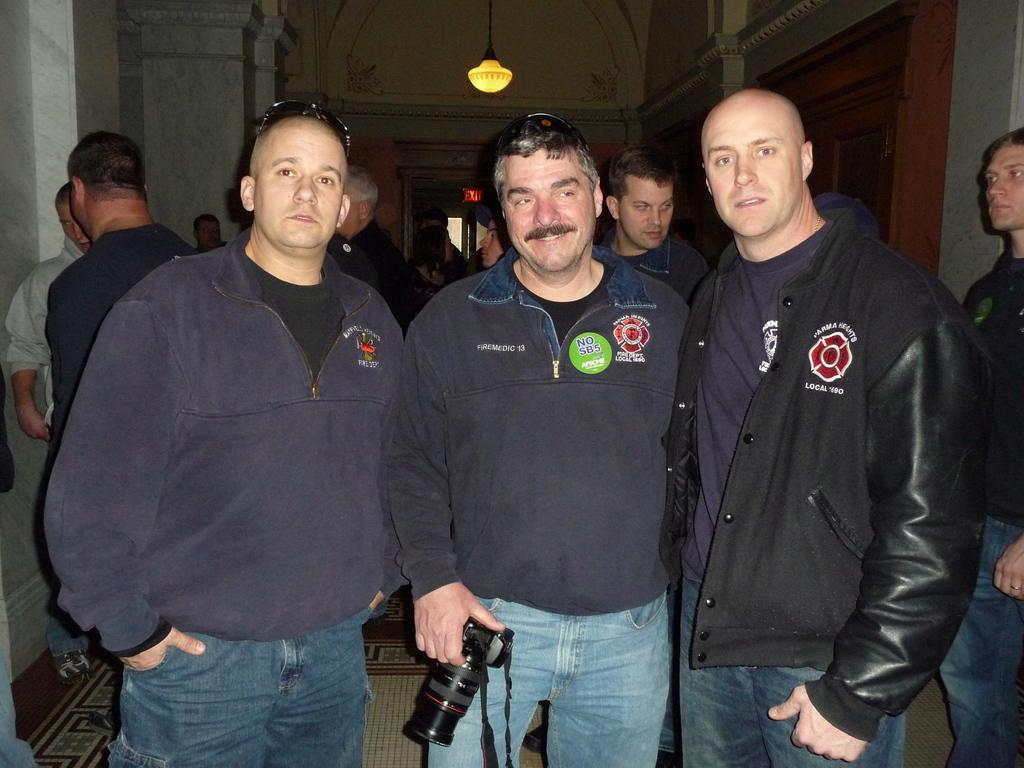How would you summarize this image in a sentence or two? In this image there are men. There is a man holding a camera in his hand. In the background of the image there is wall. There is a door. There is a light to the ceiling. At the bottom of the image there is carpet. 